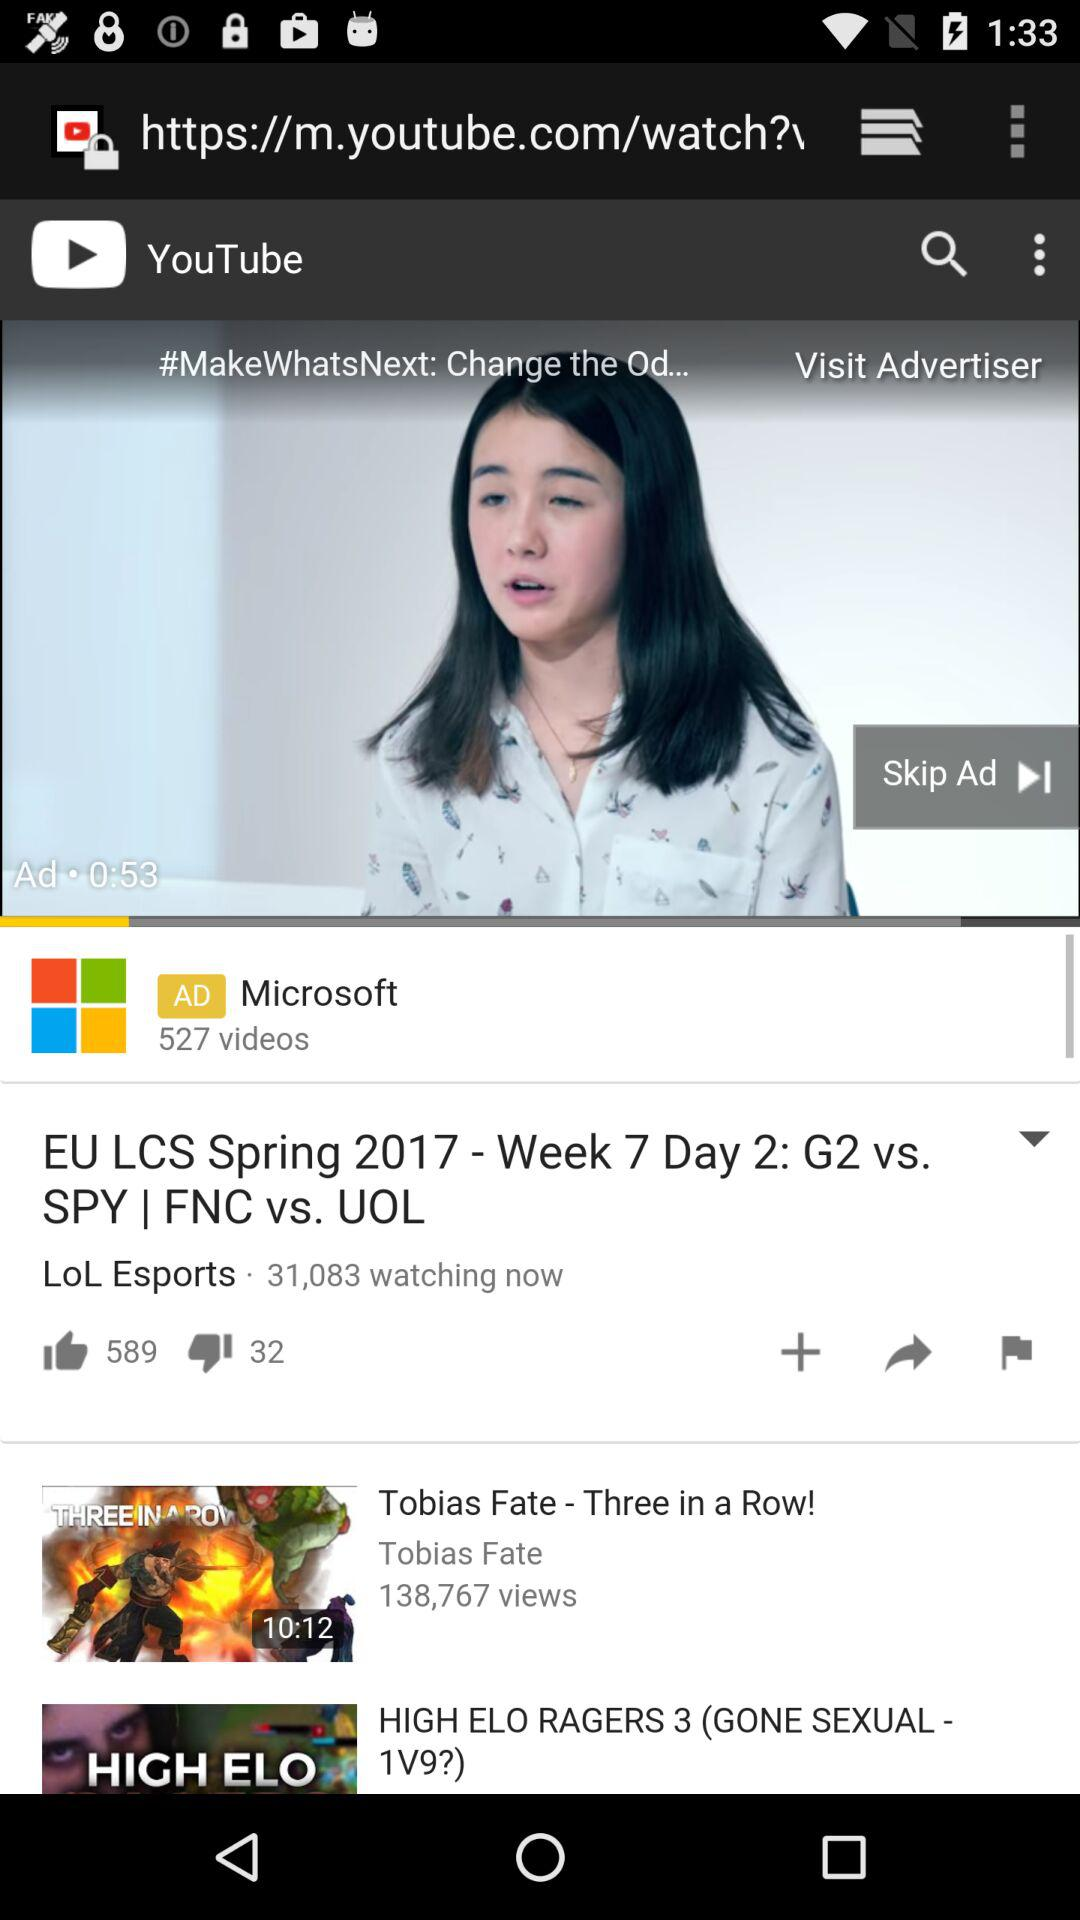How many views are on "Tobias Fate"? There are 138,767 views. 